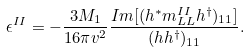Convert formula to latex. <formula><loc_0><loc_0><loc_500><loc_500>\epsilon ^ { I I } = - \frac { 3 M _ { 1 } } { 1 6 \pi v ^ { 2 } } \frac { I m [ ( h ^ { \ast } m ^ { I I } _ { L L } h ^ { \dag } ) _ { 1 1 } ] } { ( h h ^ { \dag } ) _ { 1 1 } } .</formula> 